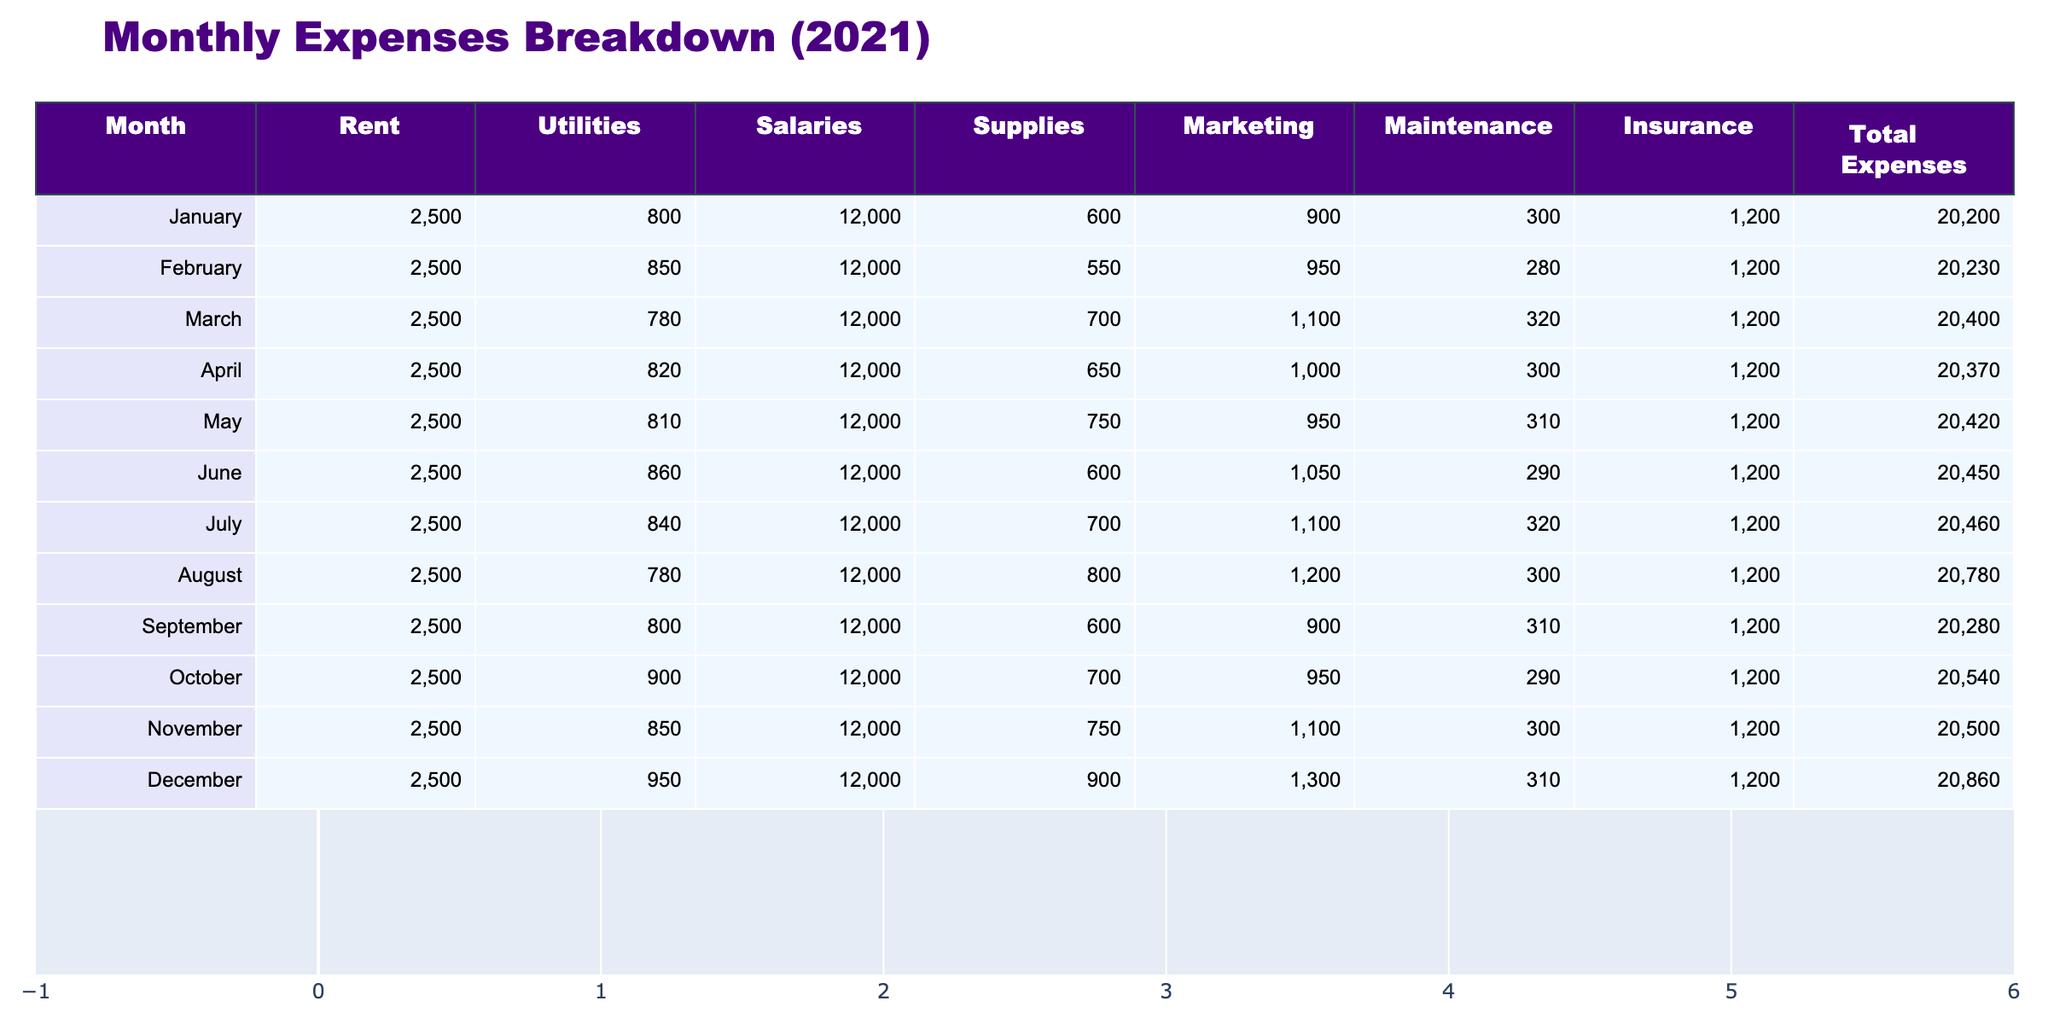What were the total expenses in June? By reviewing the table, I will locate the row for June, which shows the total expenses. The value for June is 20450.
Answer: 20450 What was the highest expense category in August? In August, I look at the various expense categories listed. Salaries is the highest amount at 12000.
Answer: Salaries What were the total expenses for the first half of the year (January to June)? I will sum the total expenses from January to June: 20200 + 20230 + 20400 + 20370 + 20420 + 20450 = 122570.
Answer: 122570 Did total expenses increase from November to December? I compare the total expenses for November (20500) and December (20860). Since December's expenses are higher than November's, the answer is yes.
Answer: Yes What is the average monthly expense throughout the year? To calculate the average, I will sum all total expenses and divide by 12: (20200 + 20230 + 20400 + 20370 + 20420 + 20450 + 20460 + 20780 + 20280 + 20540 + 20500 + 20860) = 245440. Then I divide 245440 by 12, resulting in approximately 20453.33.
Answer: 20453.33 Which month had the lowest utilities expense, and what was that amount? Reviewing the utilities column, I find that March has the lowest utilities expense at 780.
Answer: March, 780 How much more did Marketing cost than Supplies in October? In October, Marketing costs 950 and Supplies cost 700. I subtract the cost of Supplies from Marketing: 950 - 700 = 250.
Answer: 250 What was the total amount spent on marketing from January to December? I will sum the Marketing expenses from each month: 900 + 950 + 1100 + 1000 + 950 + 1050 + 1100 + 1200 + 900 + 950 + 1100 + 1300 = 12800.
Answer: 12800 Was there any month where Total Expenses exceeded 20700? By checking the Total Expenses for each month, I identify that in August (20780) and December (20860), the costs exceeded 20700. Therefore, the answer is yes.
Answer: Yes What was the difference in total expenses between the highest and lowest month? I identify the highest month expenses (December, 20860) and the lowest month expenses (January, 20200). The difference is 20860 - 20200 = 660.
Answer: 660 